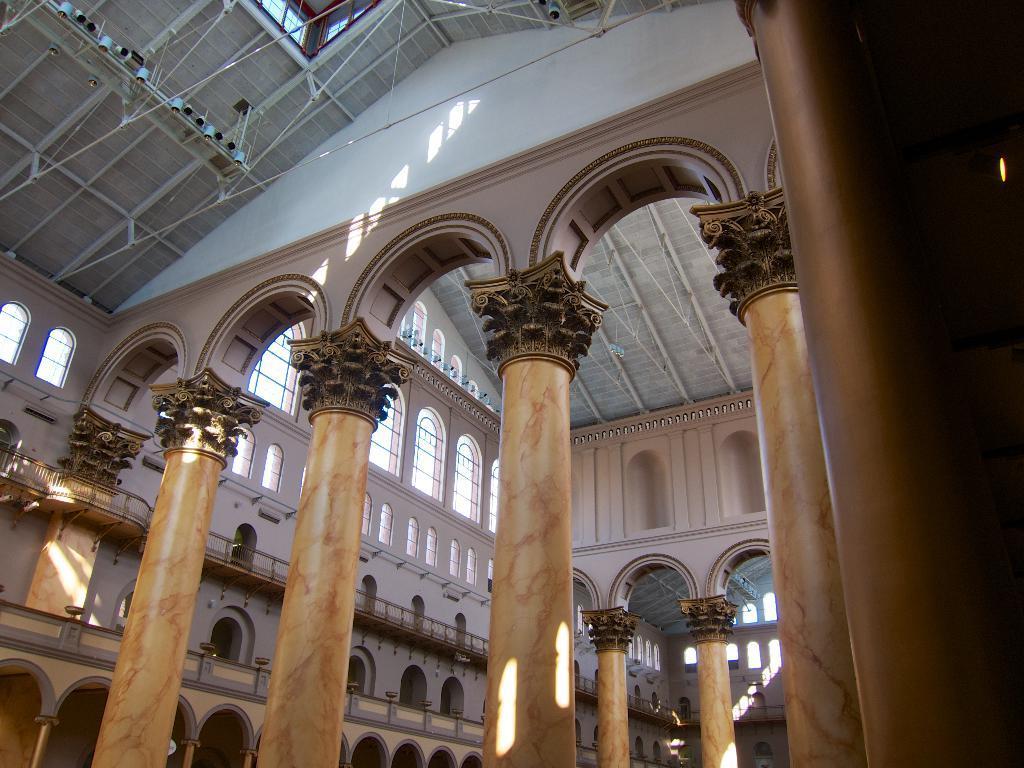In one or two sentences, can you explain what this image depicts? In this image we can see an inner view of a building containing some pillars, windows, the railing and a roof with some ceiling lights. 